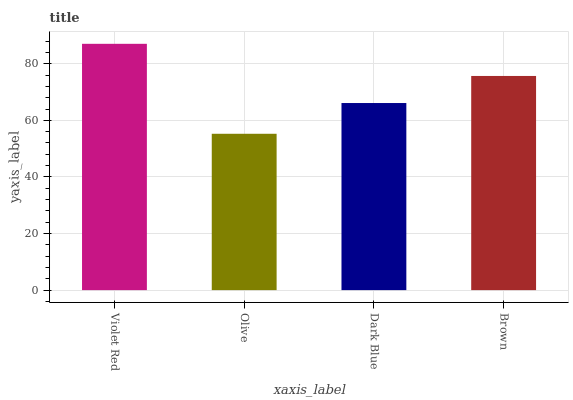Is Olive the minimum?
Answer yes or no. Yes. Is Violet Red the maximum?
Answer yes or no. Yes. Is Dark Blue the minimum?
Answer yes or no. No. Is Dark Blue the maximum?
Answer yes or no. No. Is Dark Blue greater than Olive?
Answer yes or no. Yes. Is Olive less than Dark Blue?
Answer yes or no. Yes. Is Olive greater than Dark Blue?
Answer yes or no. No. Is Dark Blue less than Olive?
Answer yes or no. No. Is Brown the high median?
Answer yes or no. Yes. Is Dark Blue the low median?
Answer yes or no. Yes. Is Olive the high median?
Answer yes or no. No. Is Brown the low median?
Answer yes or no. No. 